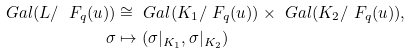Convert formula to latex. <formula><loc_0><loc_0><loc_500><loc_500>\ G a l ( L / \ F _ { q } ( u ) ) & \cong \ G a l ( K _ { 1 } / \ F _ { q } ( u ) ) \times \ G a l ( K _ { 2 } / \ F _ { q } ( u ) ) , \\ \sigma & \mapsto ( \sigma | _ { K _ { 1 } } , \sigma | _ { K _ { 2 } } )</formula> 